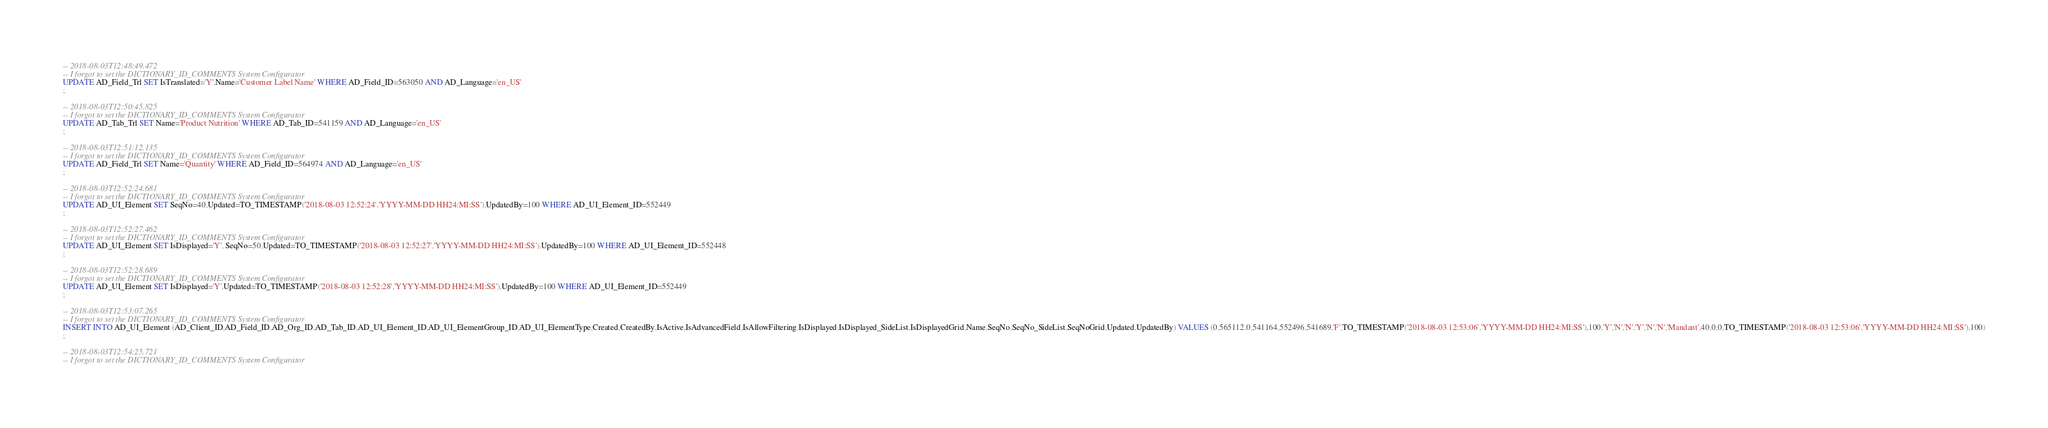<code> <loc_0><loc_0><loc_500><loc_500><_SQL_>-- 2018-08-03T12:48:49.472
-- I forgot to set the DICTIONARY_ID_COMMENTS System Configurator
UPDATE AD_Field_Trl SET IsTranslated='Y',Name='Customer Label Name' WHERE AD_Field_ID=563050 AND AD_Language='en_US'
;

-- 2018-08-03T12:50:45.825
-- I forgot to set the DICTIONARY_ID_COMMENTS System Configurator
UPDATE AD_Tab_Trl SET Name='Product Nutrition' WHERE AD_Tab_ID=541159 AND AD_Language='en_US'
;

-- 2018-08-03T12:51:12.135
-- I forgot to set the DICTIONARY_ID_COMMENTS System Configurator
UPDATE AD_Field_Trl SET Name='Quantity' WHERE AD_Field_ID=564974 AND AD_Language='en_US'
;

-- 2018-08-03T12:52:24.681
-- I forgot to set the DICTIONARY_ID_COMMENTS System Configurator
UPDATE AD_UI_Element SET SeqNo=40,Updated=TO_TIMESTAMP('2018-08-03 12:52:24','YYYY-MM-DD HH24:MI:SS'),UpdatedBy=100 WHERE AD_UI_Element_ID=552449
;

-- 2018-08-03T12:52:27.462
-- I forgot to set the DICTIONARY_ID_COMMENTS System Configurator
UPDATE AD_UI_Element SET IsDisplayed='Y', SeqNo=50,Updated=TO_TIMESTAMP('2018-08-03 12:52:27','YYYY-MM-DD HH24:MI:SS'),UpdatedBy=100 WHERE AD_UI_Element_ID=552448
;

-- 2018-08-03T12:52:28.689
-- I forgot to set the DICTIONARY_ID_COMMENTS System Configurator
UPDATE AD_UI_Element SET IsDisplayed='Y',Updated=TO_TIMESTAMP('2018-08-03 12:52:28','YYYY-MM-DD HH24:MI:SS'),UpdatedBy=100 WHERE AD_UI_Element_ID=552449
;

-- 2018-08-03T12:53:07.265
-- I forgot to set the DICTIONARY_ID_COMMENTS System Configurator
INSERT INTO AD_UI_Element (AD_Client_ID,AD_Field_ID,AD_Org_ID,AD_Tab_ID,AD_UI_Element_ID,AD_UI_ElementGroup_ID,AD_UI_ElementType,Created,CreatedBy,IsActive,IsAdvancedField,IsAllowFiltering,IsDisplayed,IsDisplayed_SideList,IsDisplayedGrid,Name,SeqNo,SeqNo_SideList,SeqNoGrid,Updated,UpdatedBy) VALUES (0,565112,0,541164,552496,541689,'F',TO_TIMESTAMP('2018-08-03 12:53:06','YYYY-MM-DD HH24:MI:SS'),100,'Y','N','N','Y','N','N','Mandant',40,0,0,TO_TIMESTAMP('2018-08-03 12:53:06','YYYY-MM-DD HH24:MI:SS'),100)
;

-- 2018-08-03T12:54:25.721
-- I forgot to set the DICTIONARY_ID_COMMENTS System Configurator</code> 